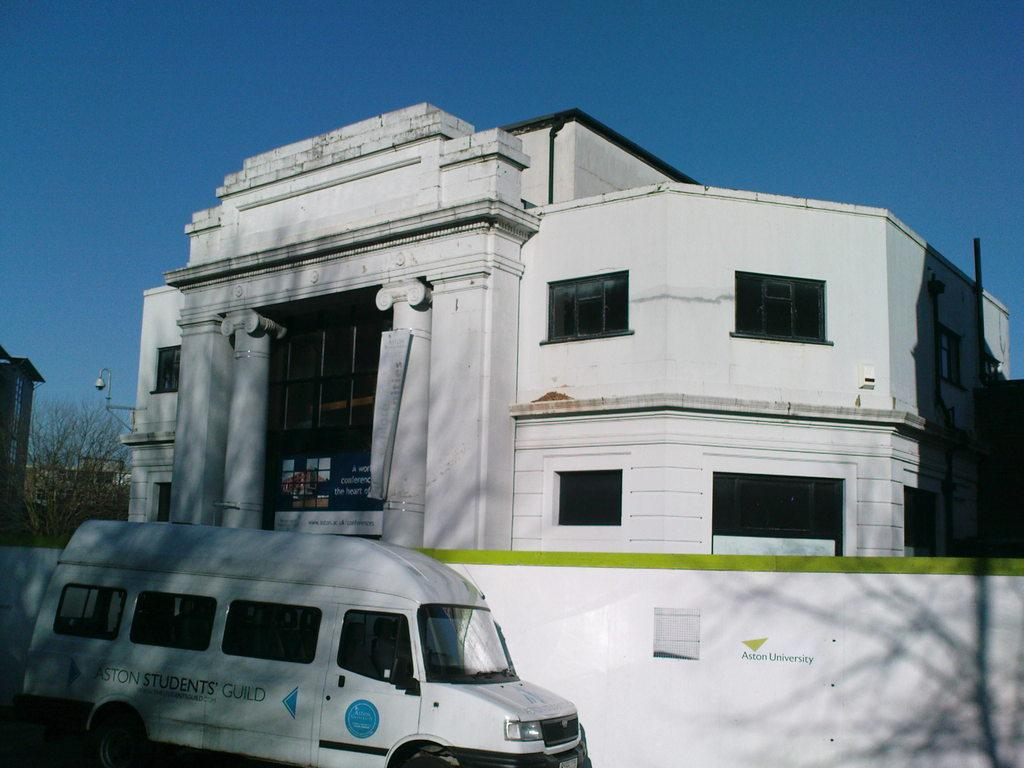What type of vehicle is in the image? There is a white color van in the image. What is located behind the van? There is a boundary wall behind the van. What can be seen beyond the boundary wall? There is a building visible behind the boundary wall. Can you describe the lighting in the image? There is a light in the image. What type of plant is in the image? There is a tree in the image. What is the color of the sky in the image? The sky is blue in color. What religion is being practiced in the image? There is no indication of any religious practice in the image. How does the system work in the image? There is no system or machinery present in the image. 